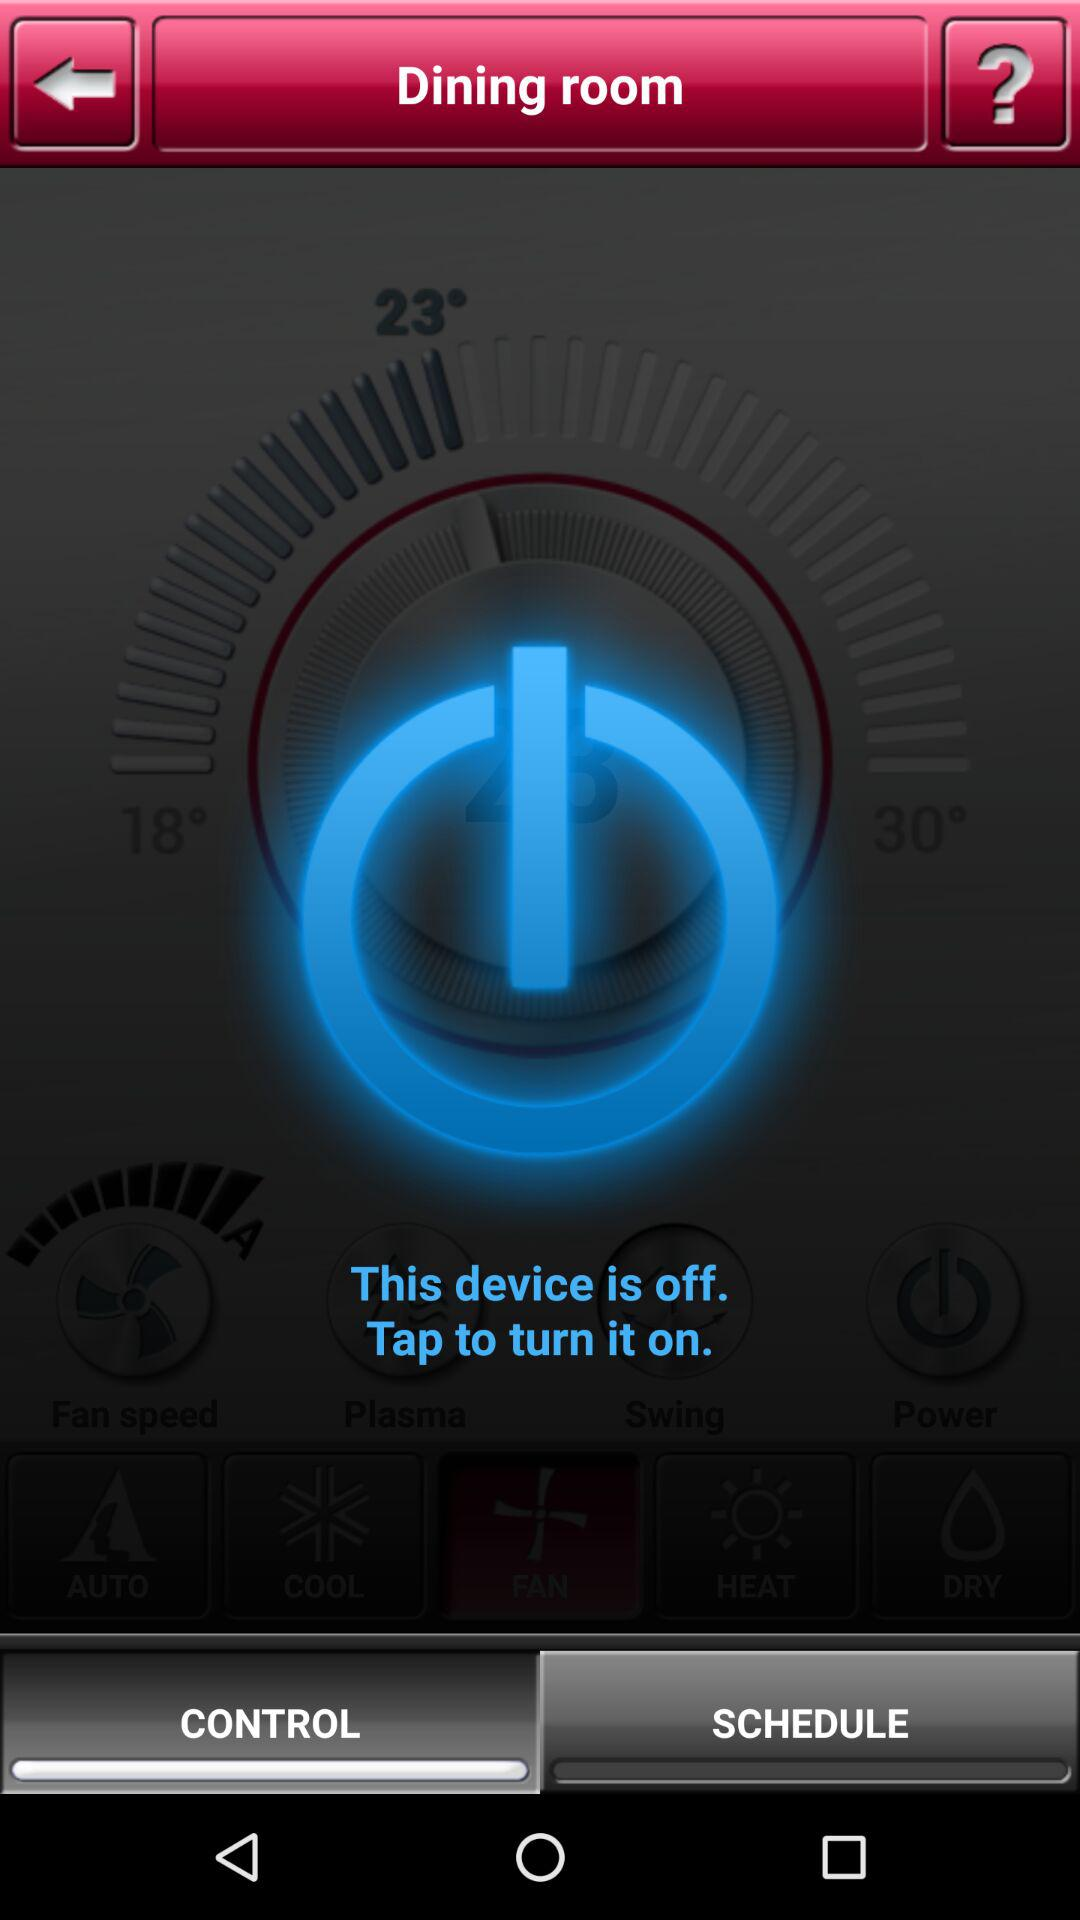How many more degrees is the target temperature than the current temperature?
Answer the question using a single word or phrase. 7 